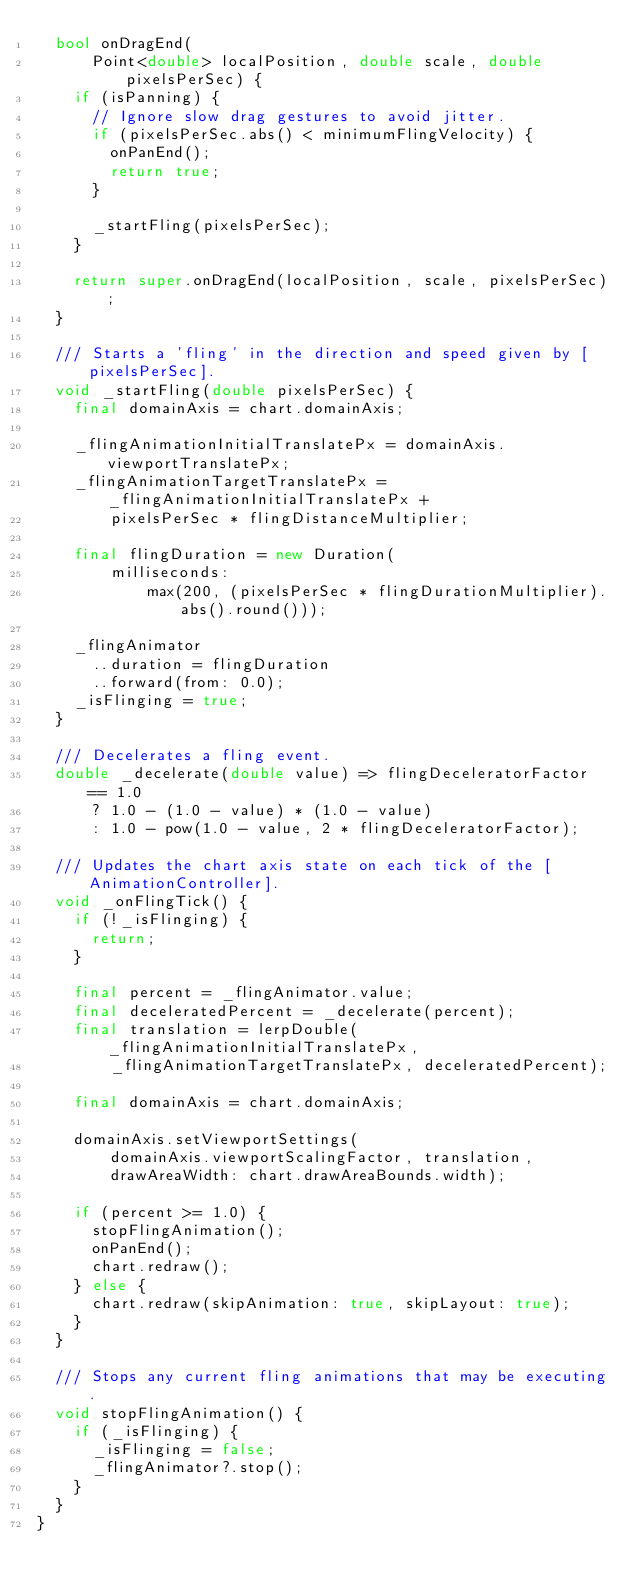<code> <loc_0><loc_0><loc_500><loc_500><_Dart_>  bool onDragEnd(
      Point<double> localPosition, double scale, double pixelsPerSec) {
    if (isPanning) {
      // Ignore slow drag gestures to avoid jitter.
      if (pixelsPerSec.abs() < minimumFlingVelocity) {
        onPanEnd();
        return true;
      }

      _startFling(pixelsPerSec);
    }

    return super.onDragEnd(localPosition, scale, pixelsPerSec);
  }

  /// Starts a 'fling' in the direction and speed given by [pixelsPerSec].
  void _startFling(double pixelsPerSec) {
    final domainAxis = chart.domainAxis;

    _flingAnimationInitialTranslatePx = domainAxis.viewportTranslatePx;
    _flingAnimationTargetTranslatePx = _flingAnimationInitialTranslatePx +
        pixelsPerSec * flingDistanceMultiplier;

    final flingDuration = new Duration(
        milliseconds:
            max(200, (pixelsPerSec * flingDurationMultiplier).abs().round()));

    _flingAnimator
      ..duration = flingDuration
      ..forward(from: 0.0);
    _isFlinging = true;
  }

  /// Decelerates a fling event.
  double _decelerate(double value) => flingDeceleratorFactor == 1.0
      ? 1.0 - (1.0 - value) * (1.0 - value)
      : 1.0 - pow(1.0 - value, 2 * flingDeceleratorFactor);

  /// Updates the chart axis state on each tick of the [AnimationController].
  void _onFlingTick() {
    if (!_isFlinging) {
      return;
    }

    final percent = _flingAnimator.value;
    final deceleratedPercent = _decelerate(percent);
    final translation = lerpDouble(_flingAnimationInitialTranslatePx,
        _flingAnimationTargetTranslatePx, deceleratedPercent);

    final domainAxis = chart.domainAxis;

    domainAxis.setViewportSettings(
        domainAxis.viewportScalingFactor, translation,
        drawAreaWidth: chart.drawAreaBounds.width);

    if (percent >= 1.0) {
      stopFlingAnimation();
      onPanEnd();
      chart.redraw();
    } else {
      chart.redraw(skipAnimation: true, skipLayout: true);
    }
  }

  /// Stops any current fling animations that may be executing.
  void stopFlingAnimation() {
    if (_isFlinging) {
      _isFlinging = false;
      _flingAnimator?.stop();
    }
  }
}
</code> 